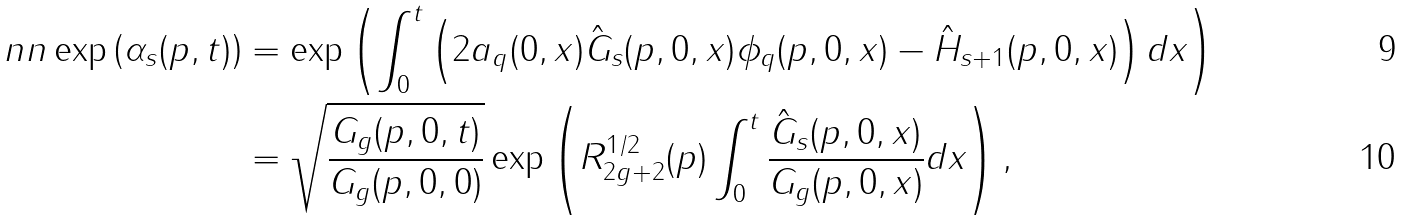Convert formula to latex. <formula><loc_0><loc_0><loc_500><loc_500>\ n n \exp \left ( \alpha _ { s } ( p , t ) \right ) & = \exp \left ( \int _ { 0 } ^ { t } \left ( 2 a _ { q } ( 0 , x ) \hat { G } _ { s } ( p , 0 , x ) \phi _ { q } ( p , 0 , x ) - \hat { H } _ { s + 1 } ( p , 0 , x ) \right ) d x \right ) \\ & = \sqrt { \frac { G _ { g } ( p , 0 , t ) } { G _ { g } ( p , 0 , 0 ) } } \exp \left ( R ^ { 1 / 2 } _ { 2 g + 2 } ( p ) \int _ { 0 } ^ { t } \frac { \hat { G } _ { s } ( p , 0 , x ) } { G _ { g } ( p , 0 , x ) } d x \right ) ,</formula> 